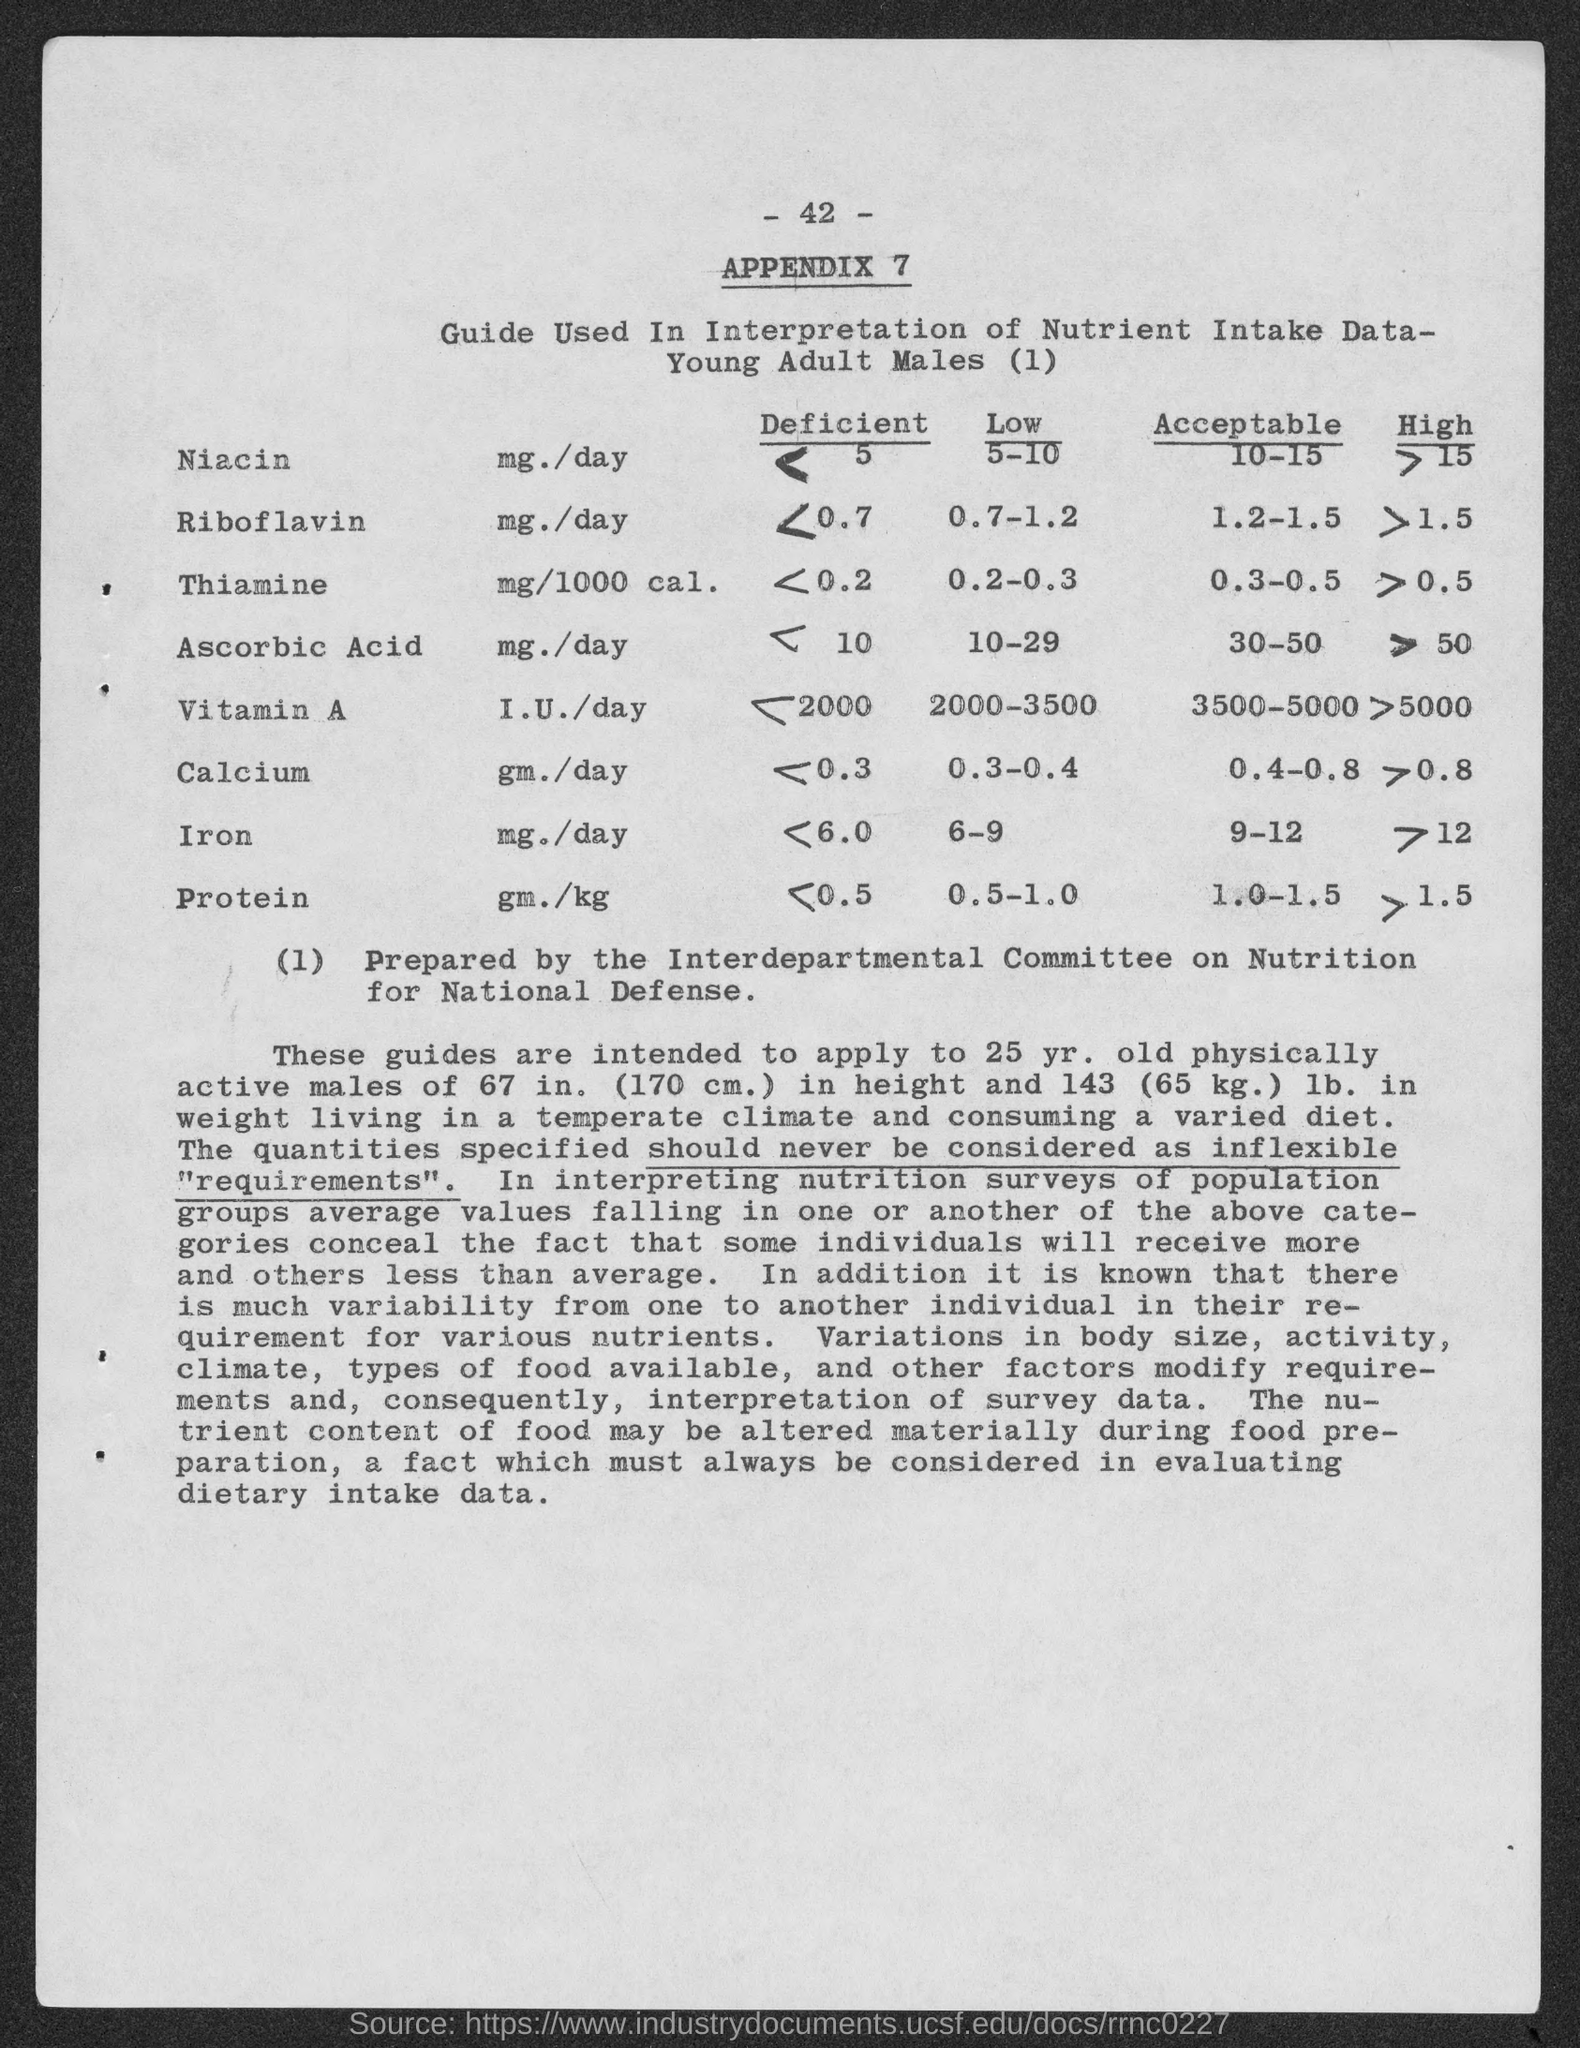List a handful of essential elements in this visual. The acceptable range of niacin in the body of a male is between 10 and 15 milligrams per deciliter. The appendix number is appendix 7. The acceptable range of iron in the body of a male is 9 to 12 micrograms per deciliter. The acceptable range of protein in the body of a male is 1.0 to 1.5 grams per kilogram of body weight. The page number is 42. 